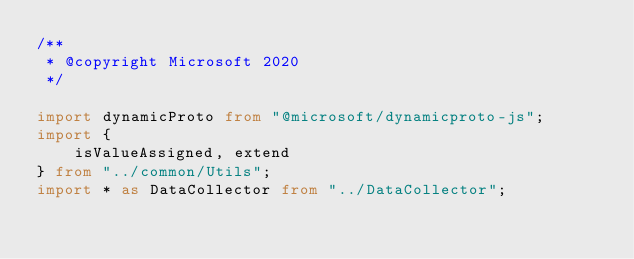Convert code to text. <code><loc_0><loc_0><loc_500><loc_500><_TypeScript_>/**
 * @copyright Microsoft 2020
 */

import dynamicProto from "@microsoft/dynamicproto-js";
import {
    isValueAssigned, extend
} from "../common/Utils";
import * as DataCollector from "../DataCollector";</code> 